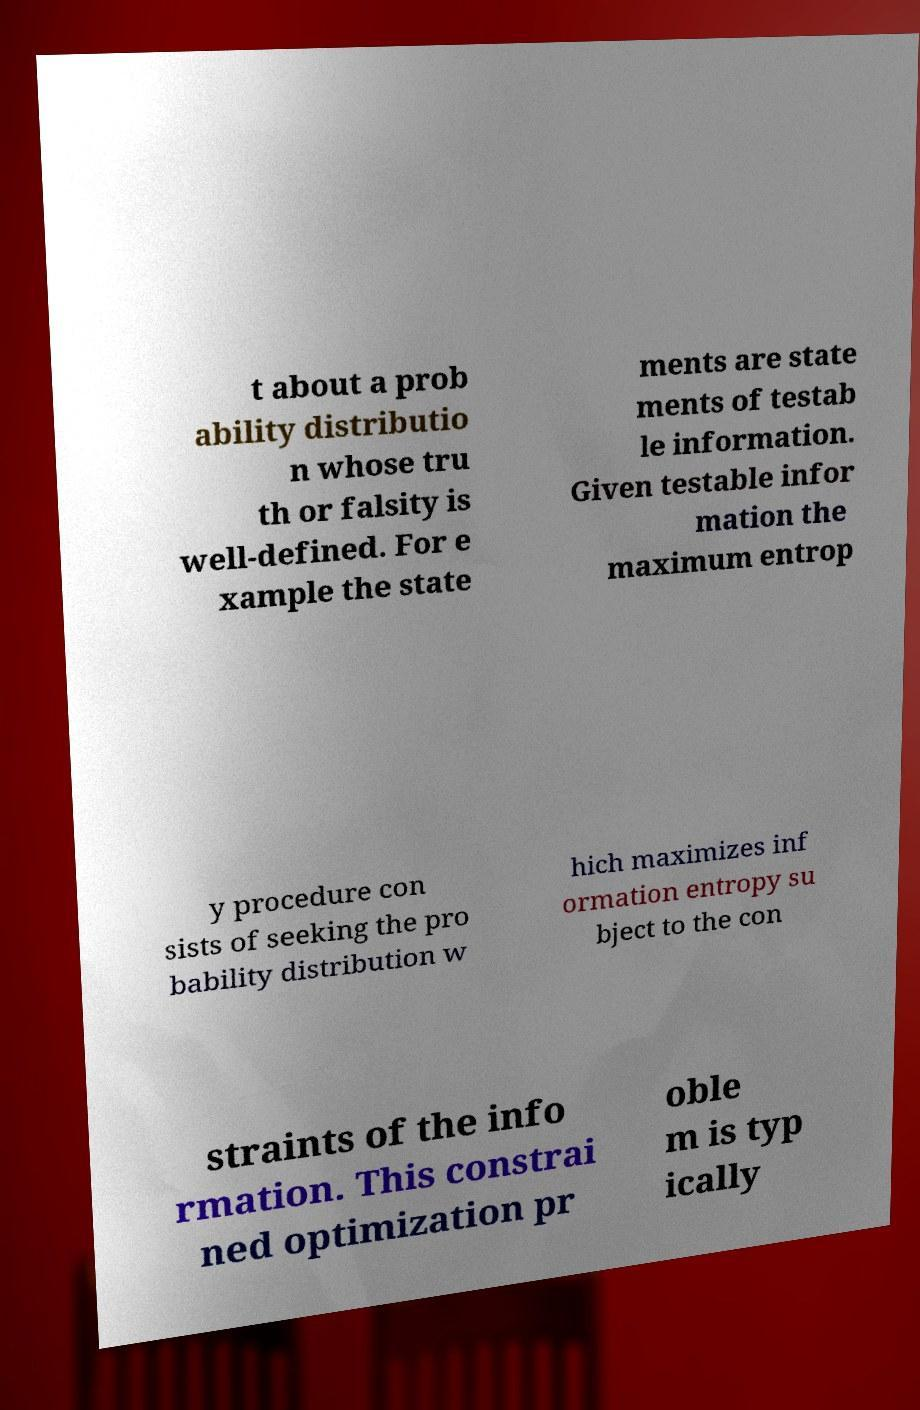Could you extract and type out the text from this image? t about a prob ability distributio n whose tru th or falsity is well-defined. For e xample the state ments are state ments of testab le information. Given testable infor mation the maximum entrop y procedure con sists of seeking the pro bability distribution w hich maximizes inf ormation entropy su bject to the con straints of the info rmation. This constrai ned optimization pr oble m is typ ically 